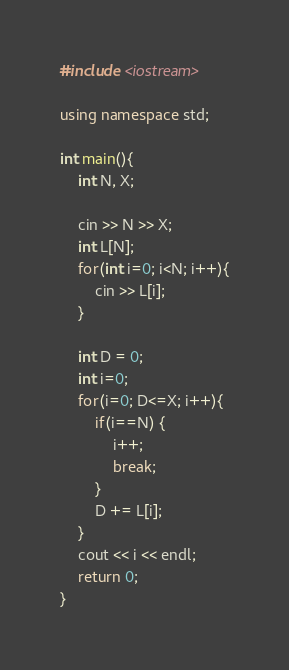<code> <loc_0><loc_0><loc_500><loc_500><_C++_>#include <iostream>

using namespace std;

int main(){
    int N, X;
    
    cin >> N >> X;
    int L[N];
    for(int i=0; i<N; i++){
        cin >> L[i];
    }

    int D = 0;
    int i=0;
    for(i=0; D<=X; i++){
        if(i==N) {
            i++;
            break;
        }
        D += L[i];
    }
    cout << i << endl;
    return 0;
}</code> 